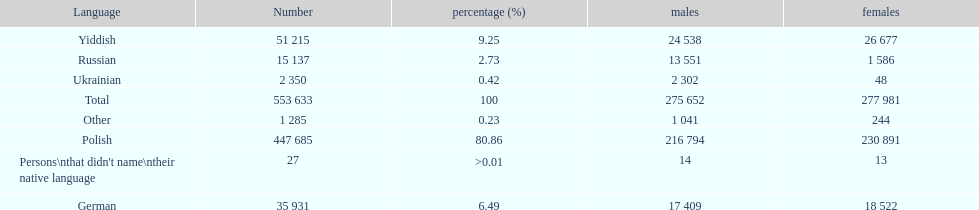Which is the least spoken language? Ukrainian. 